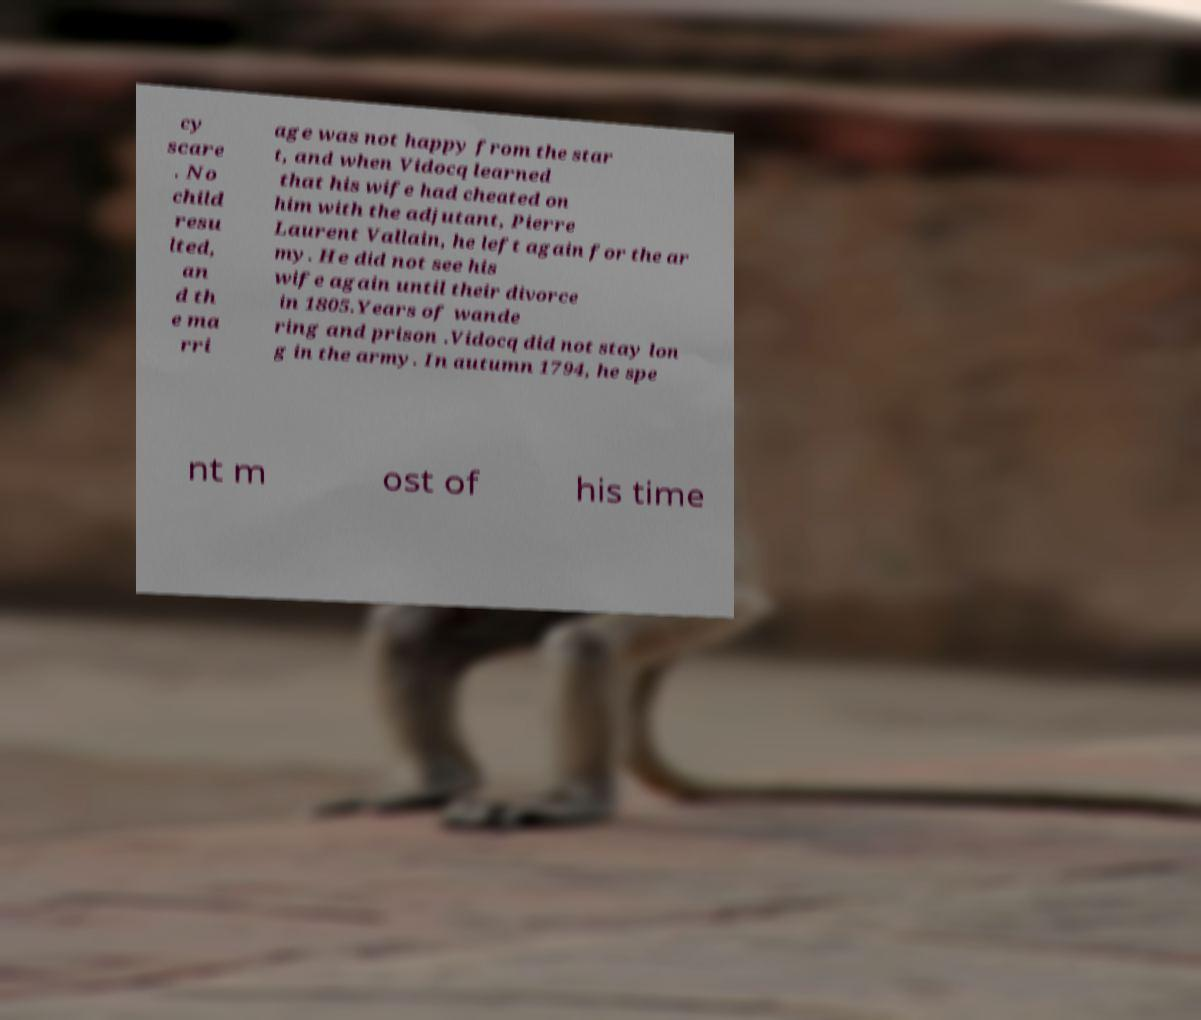Can you read and provide the text displayed in the image?This photo seems to have some interesting text. Can you extract and type it out for me? cy scare . No child resu lted, an d th e ma rri age was not happy from the star t, and when Vidocq learned that his wife had cheated on him with the adjutant, Pierre Laurent Vallain, he left again for the ar my. He did not see his wife again until their divorce in 1805.Years of wande ring and prison .Vidocq did not stay lon g in the army. In autumn 1794, he spe nt m ost of his time 